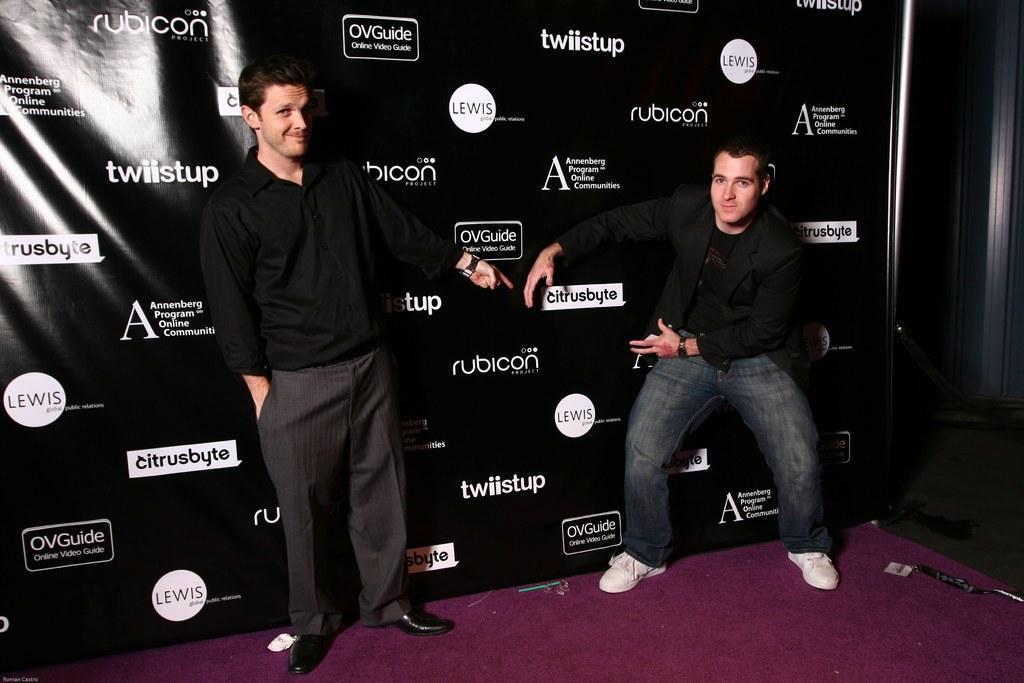Please provide a concise description of this image. In the foreground of this image, there are two men standing on the stage in front of a banner wall. 